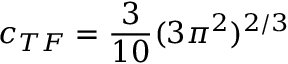<formula> <loc_0><loc_0><loc_500><loc_500>c _ { T F } = \frac { 3 } { 1 0 } ( 3 \pi ^ { 2 } ) ^ { 2 / 3 }</formula> 